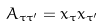Convert formula to latex. <formula><loc_0><loc_0><loc_500><loc_500>A _ { \tau \tau ^ { \prime } } = x _ { \tau } x _ { \tau ^ { \prime } }</formula> 